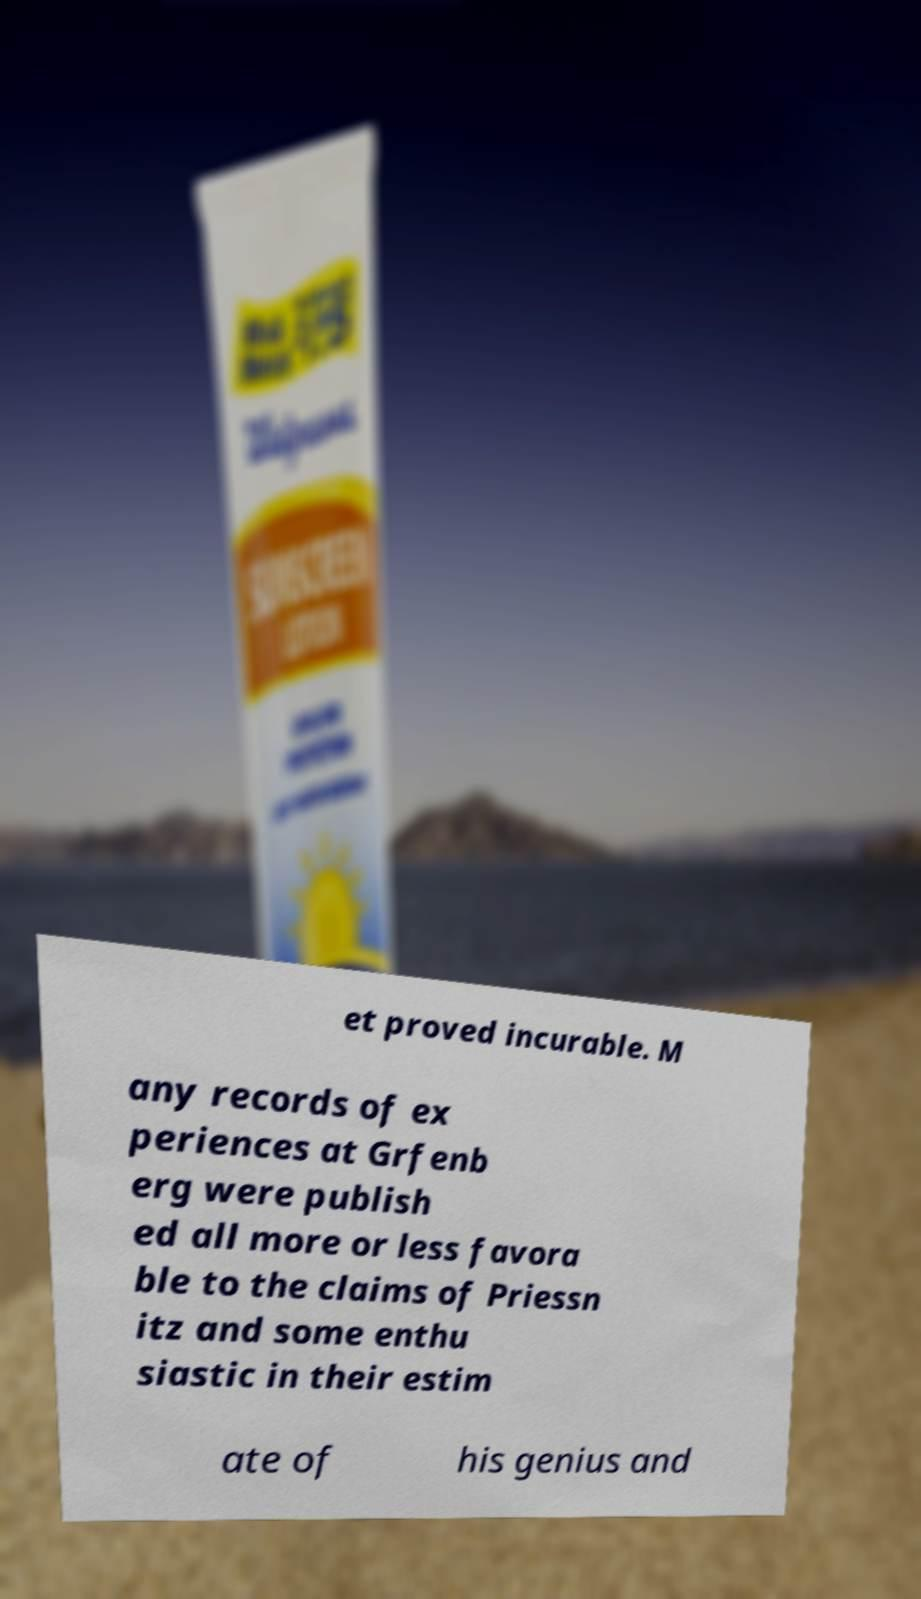I need the written content from this picture converted into text. Can you do that? et proved incurable. M any records of ex periences at Grfenb erg were publish ed all more or less favora ble to the claims of Priessn itz and some enthu siastic in their estim ate of his genius and 